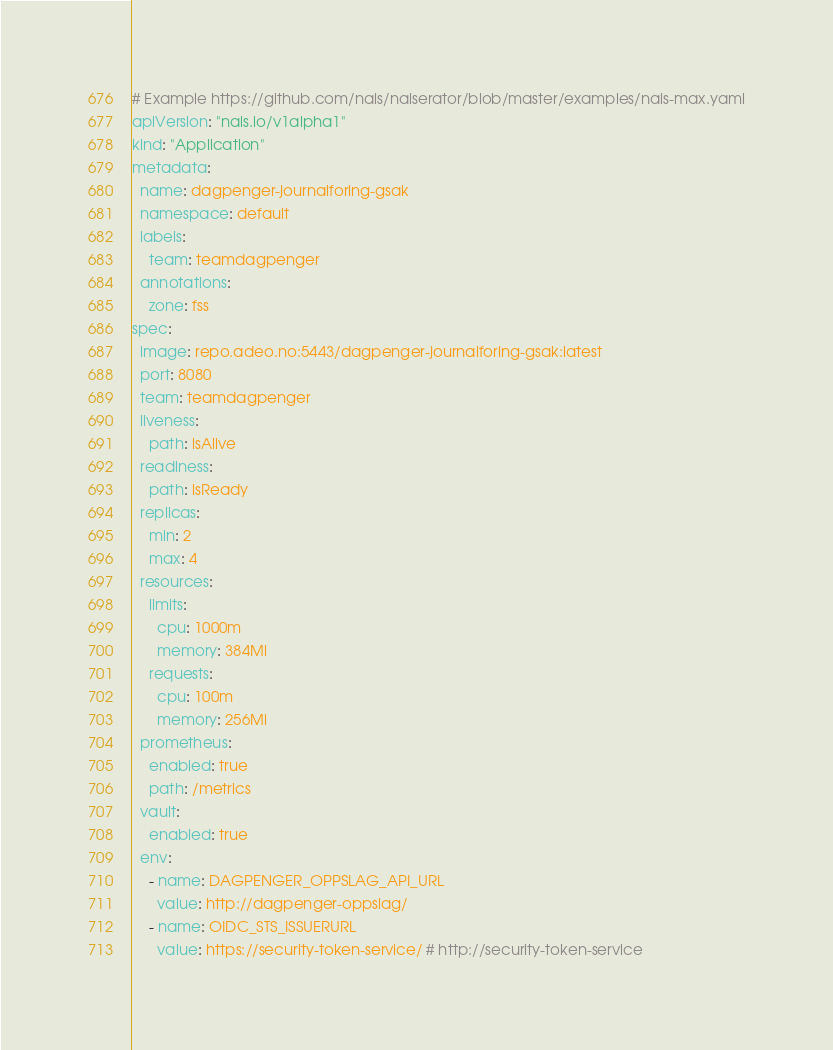<code> <loc_0><loc_0><loc_500><loc_500><_YAML_># Example https://github.com/nais/naiserator/blob/master/examples/nais-max.yaml
apiVersion: "nais.io/v1alpha1"
kind: "Application"
metadata:
  name: dagpenger-journalforing-gsak
  namespace: default
  labels:
    team: teamdagpenger
  annotations:
    zone: fss
spec:
  image: repo.adeo.no:5443/dagpenger-journalforing-gsak:latest
  port: 8080
  team: teamdagpenger
  liveness:
    path: isAlive
  readiness:
    path: isReady
  replicas:
    min: 2
    max: 4
  resources:
    limits:
      cpu: 1000m
      memory: 384Mi
    requests:
      cpu: 100m
      memory: 256Mi
  prometheus:
    enabled: true
    path: /metrics
  vault:
    enabled: true
  env:
    - name: DAGPENGER_OPPSLAG_API_URL
      value: http://dagpenger-oppslag/
    - name: OIDC_STS_ISSUERURL
      value: https://security-token-service/ # http://security-token-service
</code> 